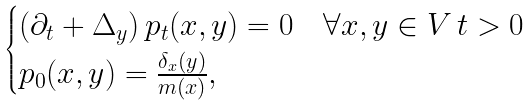Convert formula to latex. <formula><loc_0><loc_0><loc_500><loc_500>\begin{cases} ( \partial _ { t } + \Delta _ { y } ) \, p _ { t } ( x , y ) = 0 & \forall x , y \in V \, t > 0 \\ p _ { 0 } ( x , y ) = \frac { \delta _ { x } ( y ) } { m ( x ) } , \\ \end{cases}</formula> 